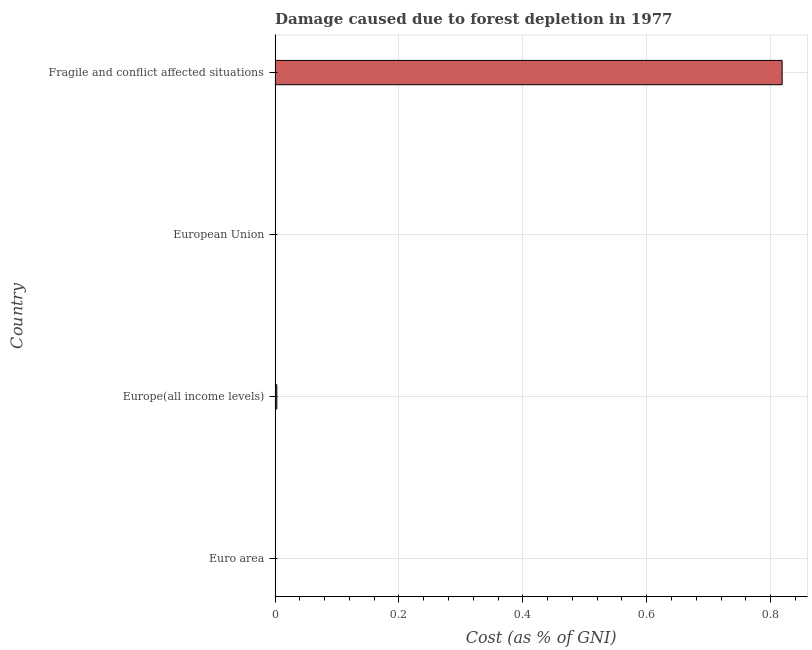Does the graph contain grids?
Provide a short and direct response. Yes. What is the title of the graph?
Provide a short and direct response. Damage caused due to forest depletion in 1977. What is the label or title of the X-axis?
Provide a short and direct response. Cost (as % of GNI). What is the damage caused due to forest depletion in Europe(all income levels)?
Provide a short and direct response. 0. Across all countries, what is the maximum damage caused due to forest depletion?
Provide a succinct answer. 0.82. Across all countries, what is the minimum damage caused due to forest depletion?
Give a very brief answer. 7.88704013507025e-5. In which country was the damage caused due to forest depletion maximum?
Give a very brief answer. Fragile and conflict affected situations. What is the sum of the damage caused due to forest depletion?
Offer a very short reply. 0.82. What is the difference between the damage caused due to forest depletion in Euro area and European Union?
Your response must be concise. 0. What is the average damage caused due to forest depletion per country?
Your answer should be compact. 0.2. What is the median damage caused due to forest depletion?
Ensure brevity in your answer.  0. Is the difference between the damage caused due to forest depletion in Euro area and European Union greater than the difference between any two countries?
Provide a succinct answer. No. What is the difference between the highest and the second highest damage caused due to forest depletion?
Give a very brief answer. 0.82. What is the difference between the highest and the lowest damage caused due to forest depletion?
Provide a succinct answer. 0.82. Are all the bars in the graph horizontal?
Give a very brief answer. Yes. What is the difference between two consecutive major ticks on the X-axis?
Ensure brevity in your answer.  0.2. What is the Cost (as % of GNI) in Euro area?
Make the answer very short. 9.79343025049009e-5. What is the Cost (as % of GNI) in Europe(all income levels)?
Your answer should be very brief. 0. What is the Cost (as % of GNI) of European Union?
Your response must be concise. 7.88704013507025e-5. What is the Cost (as % of GNI) of Fragile and conflict affected situations?
Keep it short and to the point. 0.82. What is the difference between the Cost (as % of GNI) in Euro area and Europe(all income levels)?
Ensure brevity in your answer.  -0. What is the difference between the Cost (as % of GNI) in Euro area and European Union?
Your answer should be compact. 2e-5. What is the difference between the Cost (as % of GNI) in Euro area and Fragile and conflict affected situations?
Provide a short and direct response. -0.82. What is the difference between the Cost (as % of GNI) in Europe(all income levels) and European Union?
Your answer should be very brief. 0. What is the difference between the Cost (as % of GNI) in Europe(all income levels) and Fragile and conflict affected situations?
Offer a terse response. -0.82. What is the difference between the Cost (as % of GNI) in European Union and Fragile and conflict affected situations?
Your response must be concise. -0.82. What is the ratio of the Cost (as % of GNI) in Euro area to that in Europe(all income levels)?
Offer a very short reply. 0.04. What is the ratio of the Cost (as % of GNI) in Euro area to that in European Union?
Your answer should be very brief. 1.24. What is the ratio of the Cost (as % of GNI) in Euro area to that in Fragile and conflict affected situations?
Give a very brief answer. 0. What is the ratio of the Cost (as % of GNI) in Europe(all income levels) to that in European Union?
Offer a very short reply. 35.77. What is the ratio of the Cost (as % of GNI) in Europe(all income levels) to that in Fragile and conflict affected situations?
Your response must be concise. 0. What is the ratio of the Cost (as % of GNI) in European Union to that in Fragile and conflict affected situations?
Provide a succinct answer. 0. 